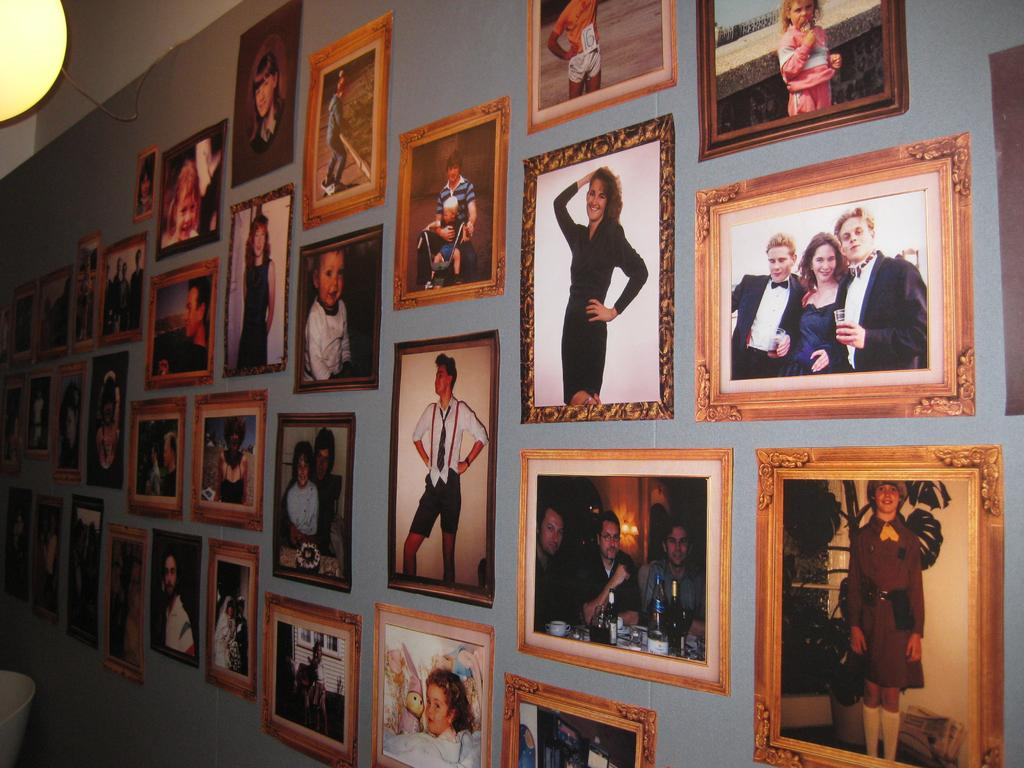What can be seen in the image that is attached to the wall? There are many frames in the image, and they are stuck to the wall. What is depicted in each of the frames? Each frame contains a photo of people. What is the source of illumination in the image? There is a light in the image. What type of wire is present in the image? There is a cable wire in the image. What type of crime is being committed on the island in the image? There is no island or crime present in the image; it features frames with photos of people on a wall. What is the chance of winning a prize in the image? There is no game or prize present in the image; it features frames with photos of people on a wall. 